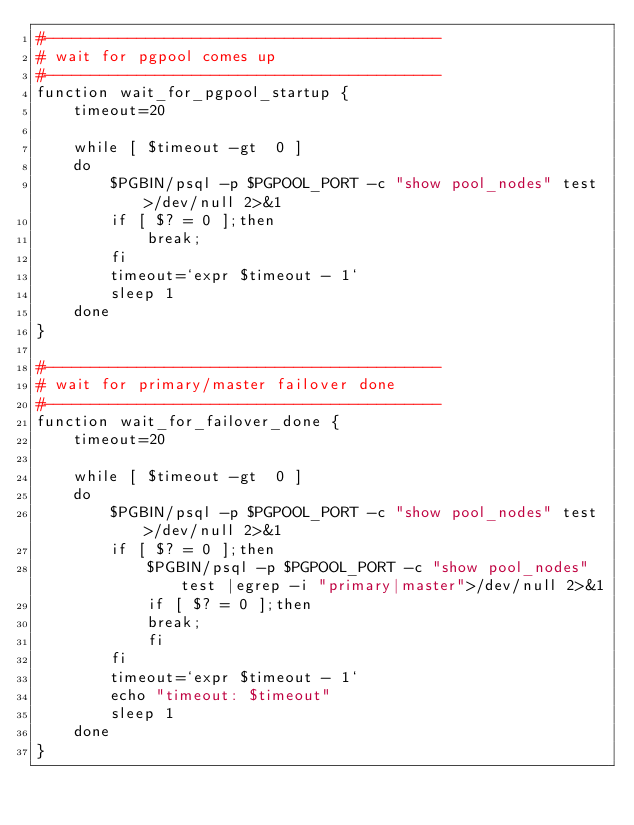Convert code to text. <code><loc_0><loc_0><loc_500><loc_500><_Bash_>#-------------------------------------------
# wait for pgpool comes up
#-------------------------------------------
function wait_for_pgpool_startup {
	timeout=20

	while [ $timeout -gt  0 ]
	do
		$PGBIN/psql -p $PGPOOL_PORT -c "show pool_nodes" test >/dev/null 2>&1
		if [ $? = 0 ];then
			break;
		fi
		timeout=`expr $timeout - 1`
		sleep 1
	done
}

#-------------------------------------------
# wait for primary/master failover done
#-------------------------------------------
function wait_for_failover_done {
	timeout=20

	while [ $timeout -gt  0 ]
	do
		$PGBIN/psql -p $PGPOOL_PORT -c "show pool_nodes" test >/dev/null 2>&1
		if [ $? = 0 ];then
		    $PGBIN/psql -p $PGPOOL_PORT -c "show pool_nodes" test |egrep -i "primary|master">/dev/null 2>&1
		    if [ $? = 0 ];then
			break;
		    fi
		fi
		timeout=`expr $timeout - 1`
		echo "timeout: $timeout"
		sleep 1
	done
}
</code> 